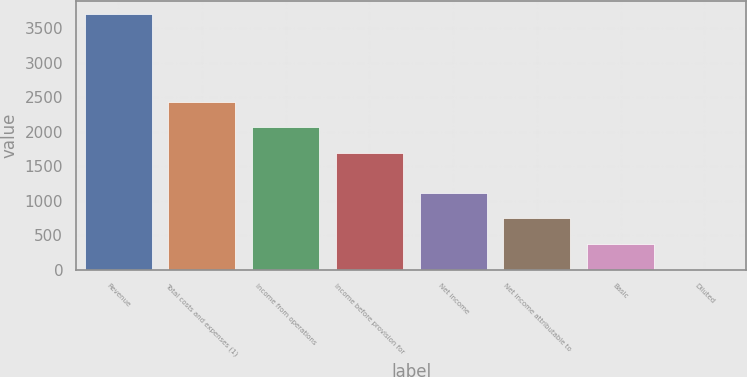<chart> <loc_0><loc_0><loc_500><loc_500><bar_chart><fcel>Revenue<fcel>Total costs and expenses (1)<fcel>Income from operations<fcel>Income before provision for<fcel>Net income<fcel>Net income attributable to<fcel>Basic<fcel>Diluted<nl><fcel>3711<fcel>2437.1<fcel>2066.05<fcel>1695<fcel>1113.61<fcel>742.56<fcel>371.51<fcel>0.46<nl></chart> 